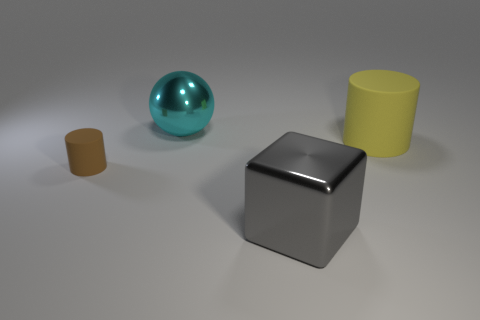Add 3 large brown spheres. How many objects exist? 7 Subtract all cubes. How many objects are left? 3 Subtract all small brown things. Subtract all matte cylinders. How many objects are left? 1 Add 1 rubber cylinders. How many rubber cylinders are left? 3 Add 1 large cylinders. How many large cylinders exist? 2 Subtract 1 gray cubes. How many objects are left? 3 